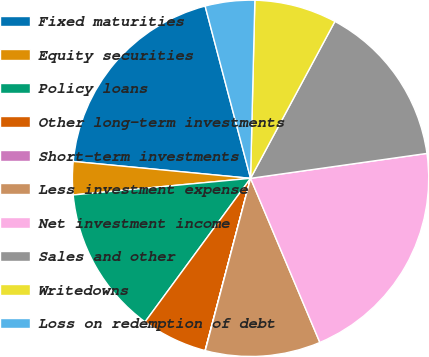Convert chart. <chart><loc_0><loc_0><loc_500><loc_500><pie_chart><fcel>Fixed maturities<fcel>Equity securities<fcel>Policy loans<fcel>Other long-term investments<fcel>Short-term investments<fcel>Less investment expense<fcel>Net investment income<fcel>Sales and other<fcel>Writedowns<fcel>Loss on redemption of debt<nl><fcel>19.39%<fcel>3.0%<fcel>13.43%<fcel>5.98%<fcel>0.02%<fcel>10.45%<fcel>20.88%<fcel>14.92%<fcel>7.47%<fcel>4.49%<nl></chart> 